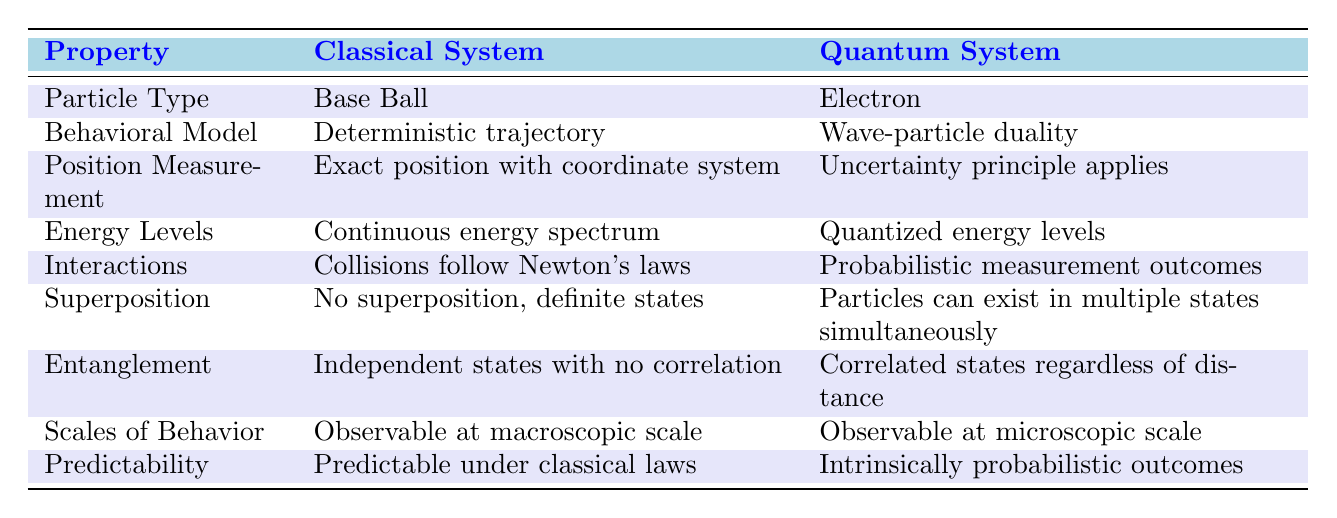What is the particle type in a classical system? The table specifies that the particle type in a classical system is a "Base Ball".
Answer: Base Ball What kind of trajectory does the quantum system exhibit? According to the table, the quantum system exhibits "Wave-particle duality".
Answer: Wave-particle duality Does the classical system exhibit superposition? The table indicates that the classical system has "No superposition, definite states", which means it does not exhibit superposition.
Answer: No Which system has a continuous energy spectrum? The table shows "Continuous energy spectrum" is a characteristic of the classical system.
Answer: Classical system What can be inferred about the energy levels of quantum systems? The table indicates that quantum systems have "Quantized energy levels", which shows they are distinct and not continuous.
Answer: Quantized energy levels How does the predictability of outcomes differ between classical and quantum systems? The classical system is "Predictable under classical laws", while the quantum system is described as having "Intrinsically probabilistic outcomes".
Answer: Predictable vs. probabilistic Which system's interactions follow Newton's laws? From the table, we see that only the classical system has interactions that "follow Newton's laws".
Answer: Classical system Are particles in the quantum system affected by the uncertain measurement of their position? The table states that in a quantum system, "Uncertainty principle applies" for position measurement, indicating it is affected.
Answer: Yes What does the term 'entanglement' imply for quantum systems? The table defines entanglement in quantum systems as having "Correlated states regardless of distance", indicating a unique property of quantum mechanics.
Answer: Correlated states How does the observable scale differ between classical and quantum systems? The table shows that the classical system is "Observable at macroscopic scale" and the quantum system at a "microscopic scale", indicating a clear difference.
Answer: Macroscopic vs. microscopic What property indicates that classical systems behave in a deterministic manner? The table points out that classical systems exhibit a "Deterministic trajectory", indicating their behavior can be predicted precisely.
Answer: Deterministic trajectory Given that quantum systems exhibit wave-particle duality, what challenge does this present to classical physics understanding? Wave-particle duality suggests that particles have both wave and particle characteristics, challenging the classical view that strictly separates these phenomena.
Answer: Challenges classical separation If a system's measurement involves uncertainty, which system does this pertain to? The table notes the "Uncertainty principle applies" for the quantum system, indicating that quantum measurements inherently involve some level of uncertainty.
Answer: Quantum system How can one differentiate between the scales of behavior of classical and quantum systems? The table highlights that classical behavior is observable at a macroscopic scale while quantum behavior is observable at a microscopic scale, thus differentiating them by scale.
Answer: Macroscopic vs. microscopic In terms of interactions, how does classical behavior compare to quantum behavior? According to the table, classical interactions are "Collisions follow Newton's laws", and quantum interactions produce "Probabilistic measurement outcomes", showing a fundamental difference in predictability.
Answer: Newton's laws vs. probabilistic outcomes Based on the table, can you summarize the overall predictability of classical versus quantum systems? The classical system is predictable, whereas the quantum system is characterized by unpredictable outcomes, which significantly alters the foundation laid by classical theories.
Answer: Predictable vs. unpredictable 